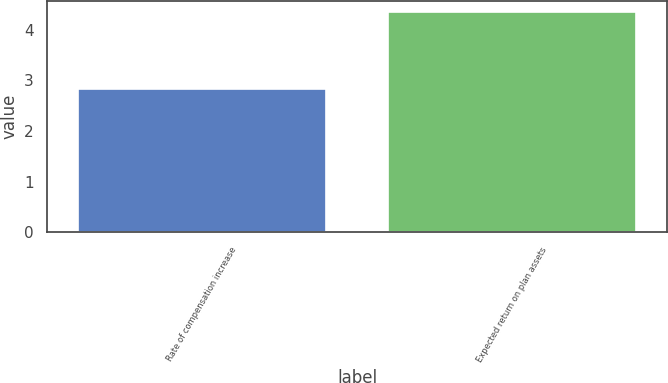<chart> <loc_0><loc_0><loc_500><loc_500><bar_chart><fcel>Rate of compensation increase<fcel>Expected return on plan assets<nl><fcel>2.83<fcel>4.35<nl></chart> 